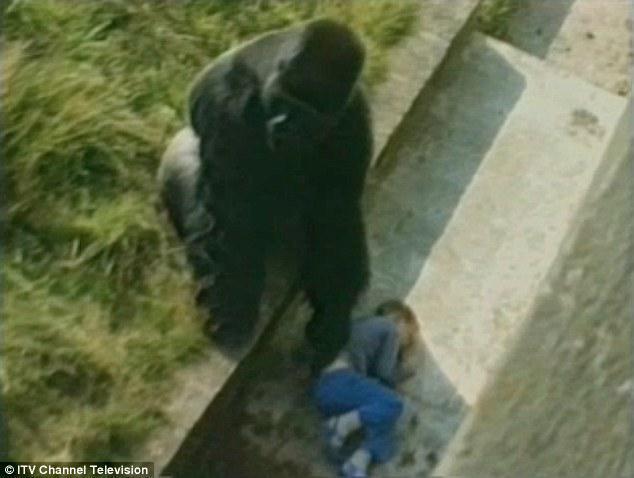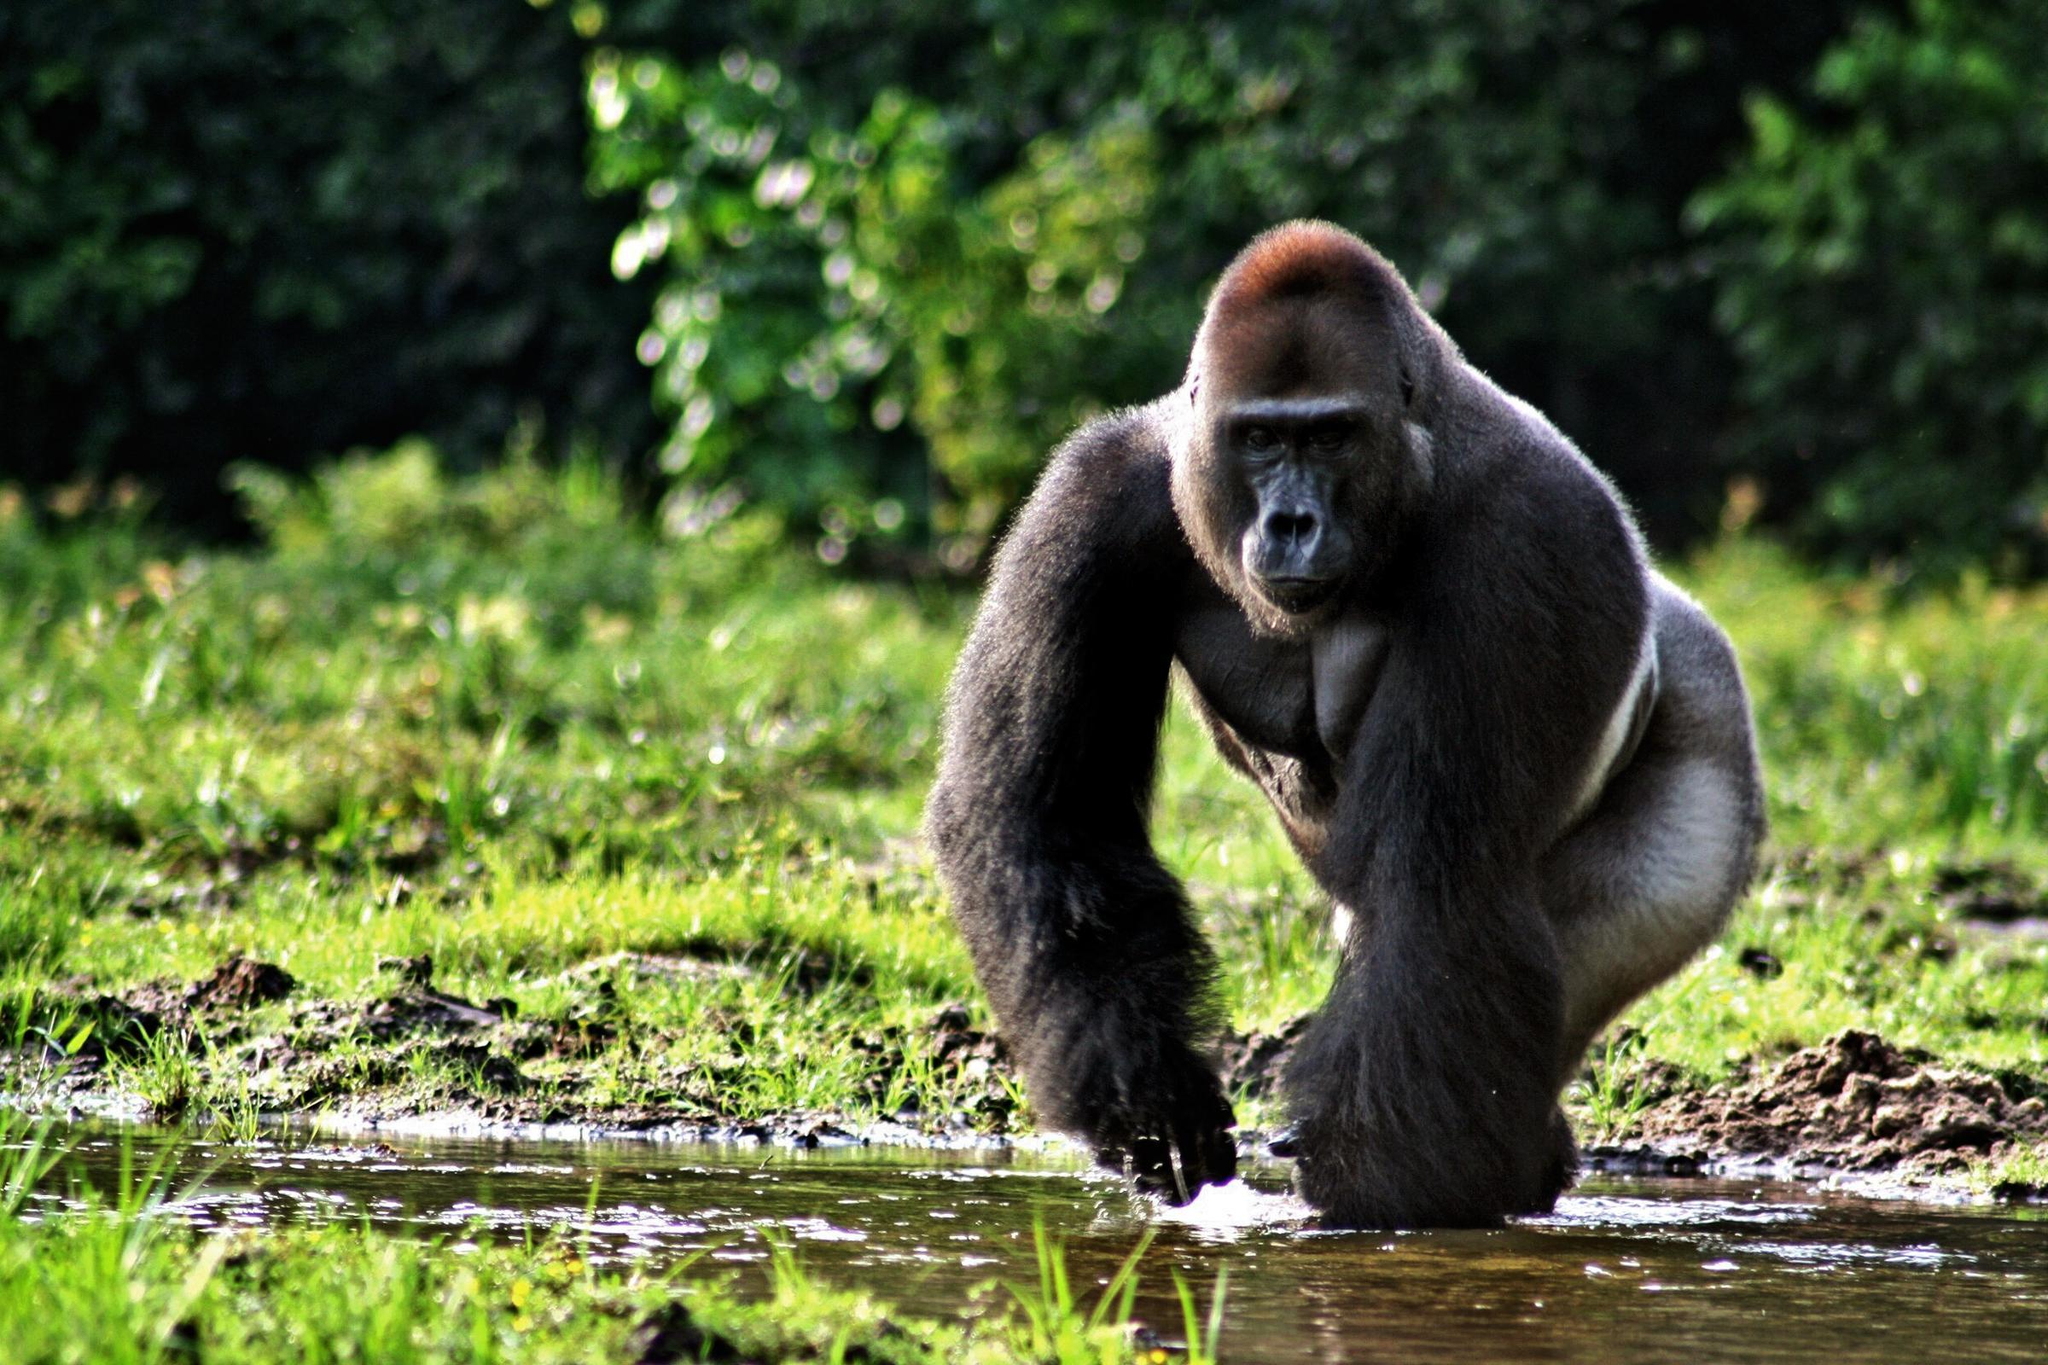The first image is the image on the left, the second image is the image on the right. Assess this claim about the two images: "Each image shows one person to the right of one gorilla, and the right image shows a gorilla face-to-face with and touching a person.". Correct or not? Answer yes or no. No. The first image is the image on the left, the second image is the image on the right. Analyze the images presented: Is the assertion "The left and right image contains the same number gorillas on the left and people on the right." valid? Answer yes or no. No. 